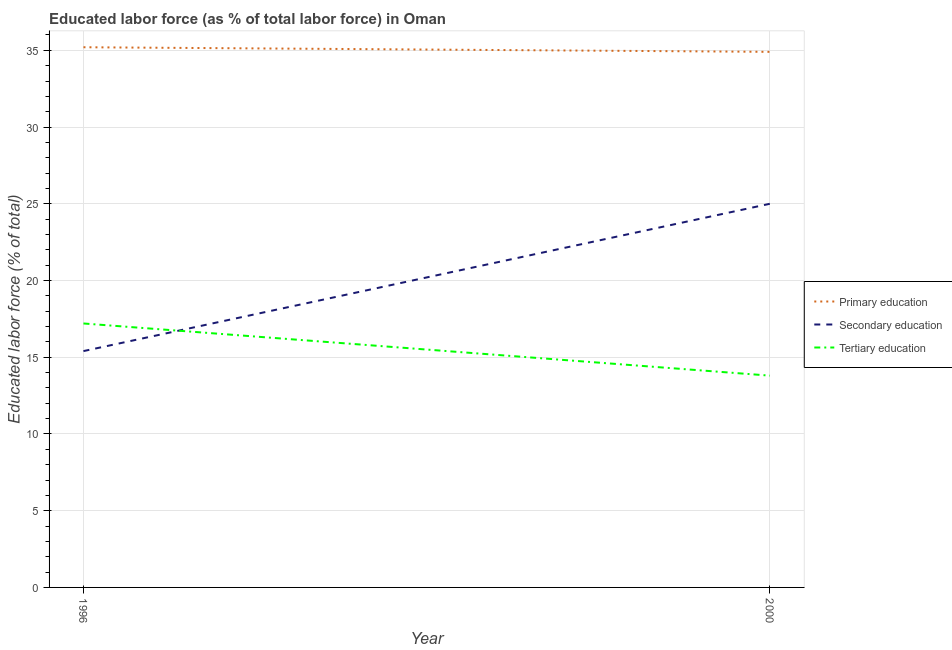How many different coloured lines are there?
Offer a very short reply. 3. Is the number of lines equal to the number of legend labels?
Offer a terse response. Yes. What is the percentage of labor force who received secondary education in 2000?
Provide a succinct answer. 25. Across all years, what is the maximum percentage of labor force who received tertiary education?
Your response must be concise. 17.2. Across all years, what is the minimum percentage of labor force who received tertiary education?
Keep it short and to the point. 13.8. In which year was the percentage of labor force who received tertiary education maximum?
Keep it short and to the point. 1996. In which year was the percentage of labor force who received tertiary education minimum?
Ensure brevity in your answer.  2000. What is the total percentage of labor force who received tertiary education in the graph?
Provide a short and direct response. 31. What is the difference between the percentage of labor force who received secondary education in 1996 and that in 2000?
Provide a short and direct response. -9.6. What is the difference between the percentage of labor force who received tertiary education in 1996 and the percentage of labor force who received primary education in 2000?
Provide a succinct answer. -17.7. What is the average percentage of labor force who received secondary education per year?
Your response must be concise. 20.2. In the year 1996, what is the difference between the percentage of labor force who received primary education and percentage of labor force who received secondary education?
Your response must be concise. 19.8. In how many years, is the percentage of labor force who received tertiary education greater than 10 %?
Provide a short and direct response. 2. What is the ratio of the percentage of labor force who received tertiary education in 1996 to that in 2000?
Your answer should be very brief. 1.25. Is the percentage of labor force who received secondary education in 1996 less than that in 2000?
Offer a terse response. Yes. Is it the case that in every year, the sum of the percentage of labor force who received primary education and percentage of labor force who received secondary education is greater than the percentage of labor force who received tertiary education?
Keep it short and to the point. Yes. Does the percentage of labor force who received primary education monotonically increase over the years?
Ensure brevity in your answer.  No. Is the percentage of labor force who received secondary education strictly greater than the percentage of labor force who received primary education over the years?
Provide a succinct answer. No. Is the percentage of labor force who received primary education strictly less than the percentage of labor force who received secondary education over the years?
Provide a succinct answer. No. How many years are there in the graph?
Keep it short and to the point. 2. Are the values on the major ticks of Y-axis written in scientific E-notation?
Offer a terse response. No. Does the graph contain any zero values?
Offer a very short reply. No. Does the graph contain grids?
Provide a short and direct response. Yes. What is the title of the graph?
Provide a succinct answer. Educated labor force (as % of total labor force) in Oman. Does "Ireland" appear as one of the legend labels in the graph?
Give a very brief answer. No. What is the label or title of the X-axis?
Your response must be concise. Year. What is the label or title of the Y-axis?
Keep it short and to the point. Educated labor force (% of total). What is the Educated labor force (% of total) of Primary education in 1996?
Your response must be concise. 35.2. What is the Educated labor force (% of total) of Secondary education in 1996?
Your response must be concise. 15.4. What is the Educated labor force (% of total) in Tertiary education in 1996?
Offer a terse response. 17.2. What is the Educated labor force (% of total) of Primary education in 2000?
Your answer should be compact. 34.9. What is the Educated labor force (% of total) in Secondary education in 2000?
Your answer should be compact. 25. What is the Educated labor force (% of total) of Tertiary education in 2000?
Your answer should be compact. 13.8. Across all years, what is the maximum Educated labor force (% of total) of Primary education?
Offer a terse response. 35.2. Across all years, what is the maximum Educated labor force (% of total) of Secondary education?
Your response must be concise. 25. Across all years, what is the maximum Educated labor force (% of total) of Tertiary education?
Make the answer very short. 17.2. Across all years, what is the minimum Educated labor force (% of total) of Primary education?
Make the answer very short. 34.9. Across all years, what is the minimum Educated labor force (% of total) in Secondary education?
Provide a succinct answer. 15.4. Across all years, what is the minimum Educated labor force (% of total) of Tertiary education?
Give a very brief answer. 13.8. What is the total Educated labor force (% of total) in Primary education in the graph?
Provide a short and direct response. 70.1. What is the total Educated labor force (% of total) in Secondary education in the graph?
Make the answer very short. 40.4. What is the total Educated labor force (% of total) in Tertiary education in the graph?
Offer a terse response. 31. What is the difference between the Educated labor force (% of total) of Primary education in 1996 and the Educated labor force (% of total) of Tertiary education in 2000?
Offer a terse response. 21.4. What is the average Educated labor force (% of total) in Primary education per year?
Your answer should be very brief. 35.05. What is the average Educated labor force (% of total) in Secondary education per year?
Your answer should be very brief. 20.2. In the year 1996, what is the difference between the Educated labor force (% of total) in Primary education and Educated labor force (% of total) in Secondary education?
Offer a very short reply. 19.8. In the year 1996, what is the difference between the Educated labor force (% of total) in Primary education and Educated labor force (% of total) in Tertiary education?
Keep it short and to the point. 18. In the year 2000, what is the difference between the Educated labor force (% of total) in Primary education and Educated labor force (% of total) in Tertiary education?
Offer a very short reply. 21.1. What is the ratio of the Educated labor force (% of total) in Primary education in 1996 to that in 2000?
Provide a succinct answer. 1.01. What is the ratio of the Educated labor force (% of total) in Secondary education in 1996 to that in 2000?
Your answer should be compact. 0.62. What is the ratio of the Educated labor force (% of total) of Tertiary education in 1996 to that in 2000?
Make the answer very short. 1.25. What is the difference between the highest and the second highest Educated labor force (% of total) of Secondary education?
Ensure brevity in your answer.  9.6. What is the difference between the highest and the lowest Educated labor force (% of total) of Tertiary education?
Provide a short and direct response. 3.4. 